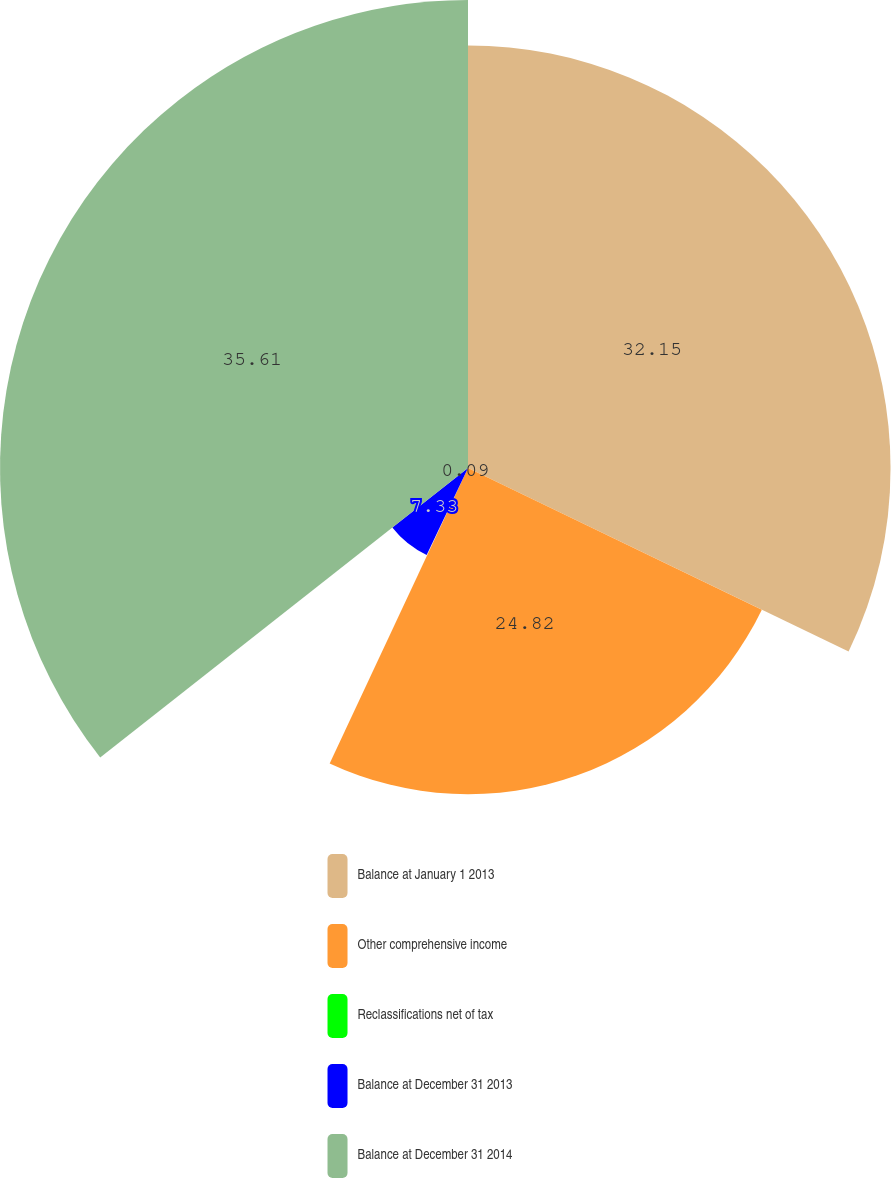Convert chart to OTSL. <chart><loc_0><loc_0><loc_500><loc_500><pie_chart><fcel>Balance at January 1 2013<fcel>Other comprehensive income<fcel>Reclassifications net of tax<fcel>Balance at December 31 2013<fcel>Balance at December 31 2014<nl><fcel>32.15%<fcel>24.82%<fcel>0.09%<fcel>7.33%<fcel>35.61%<nl></chart> 